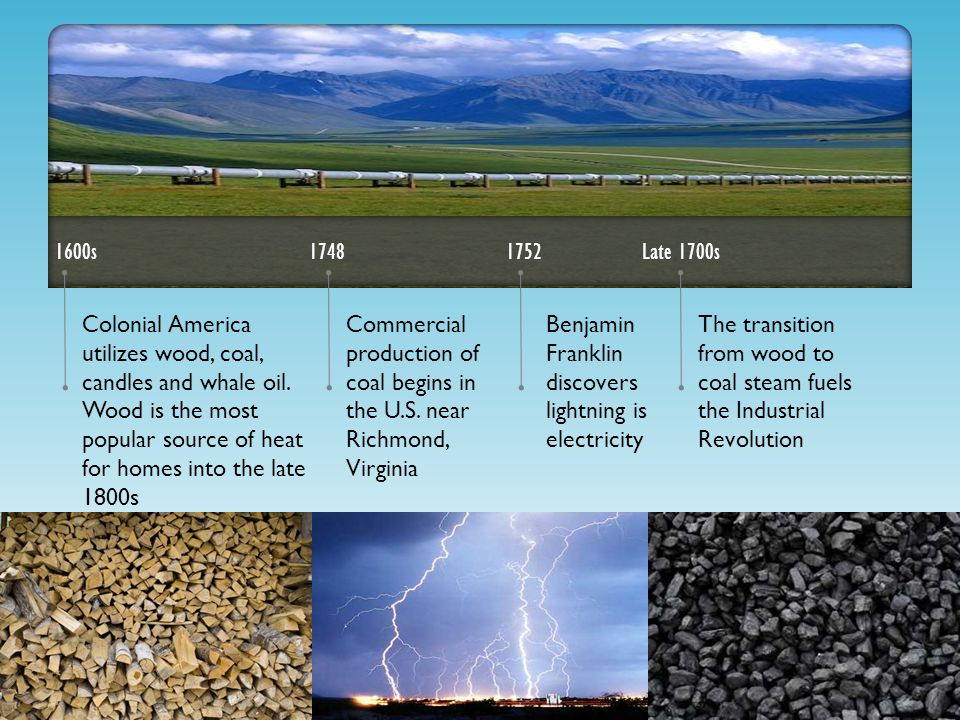Considering the dates and events described in the timeline, what might have been the social and economic implications of the transition from wood to coal as the primary energy source during the late 1700s? The image provides key dates and events that help frame the implications of the transition from wood to coal during the late 1700s. Economically, the switch to coal likely propelled industrial growth significantly, as coal is a more efficient fuel source than wood for powering steam engines. These engines were integral to major advancements during the Industrial Revolution, leading to increased productivity and economic expansion. Socially, the transition to coal may have driven significant changes in labor patterns. Many individuals likely moved to urban areas to work in coal mines and growing industrial sectors, which in turn contributed to rapid urbanization. This shift also has environmental ramifications; extensive coal mining and its use would have contributed to air and water pollution. Moreover, relying heavily on coal set a precedent in energy consumption patterns that would have long-term impacts on societal development and environmental health. 